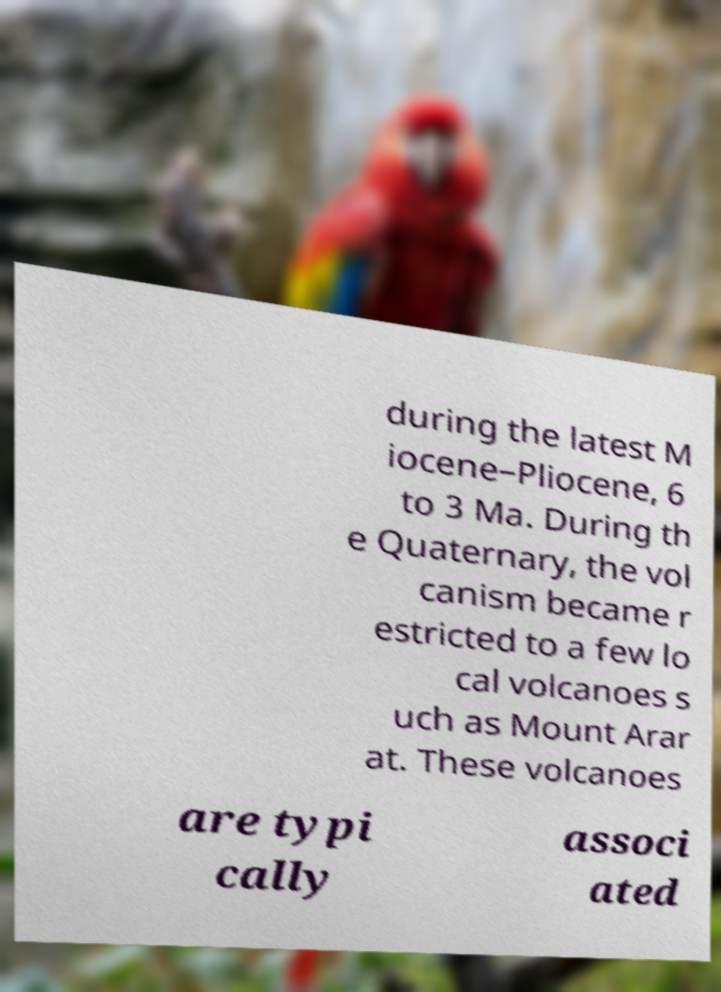Can you accurately transcribe the text from the provided image for me? during the latest M iocene–Pliocene, 6 to 3 Ma. During th e Quaternary, the vol canism became r estricted to a few lo cal volcanoes s uch as Mount Arar at. These volcanoes are typi cally associ ated 